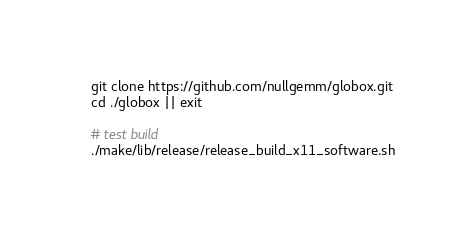<code> <loc_0><loc_0><loc_500><loc_500><_Bash_>git clone https://github.com/nullgemm/globox.git
cd ./globox || exit

# test build
./make/lib/release/release_build_x11_software.sh
</code> 